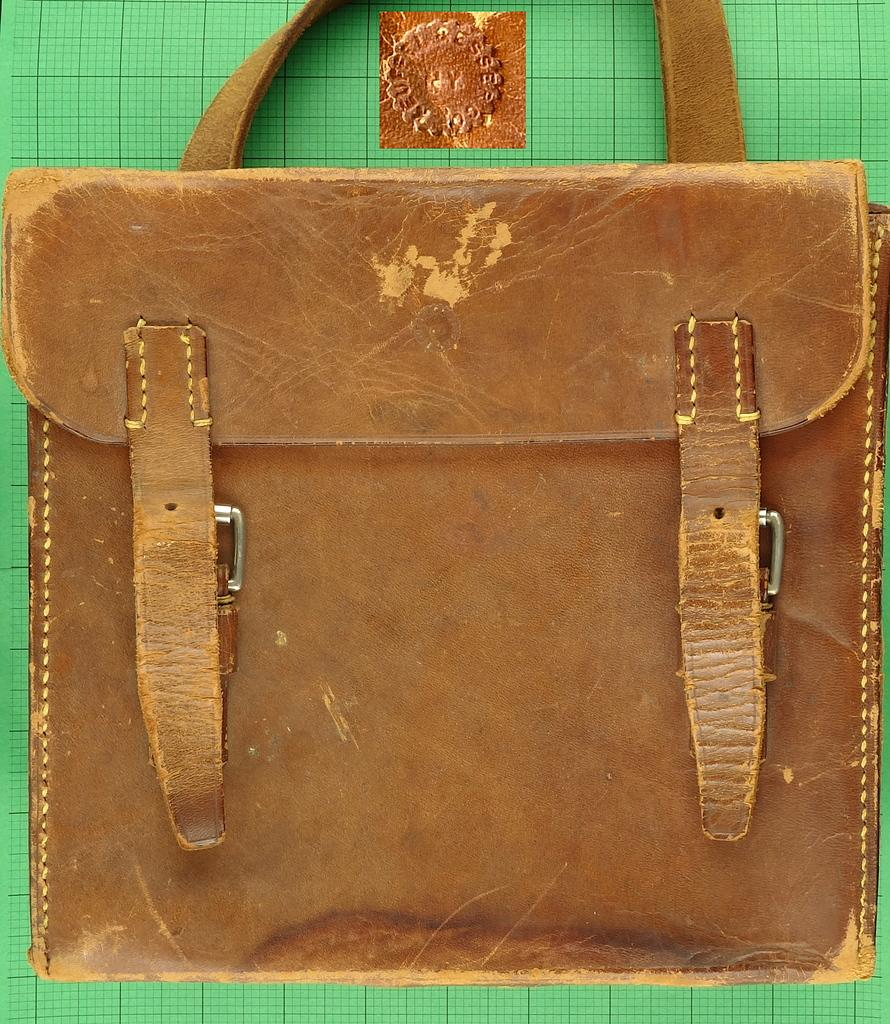What object can be seen in the image? There is a handbag in the image. What is the color of the handbag? The handbag is brown in color. Can you provide an example of a woman holding the handbag in the image? There is no woman present in the image, nor is there any indication of someone holding the handbag. 